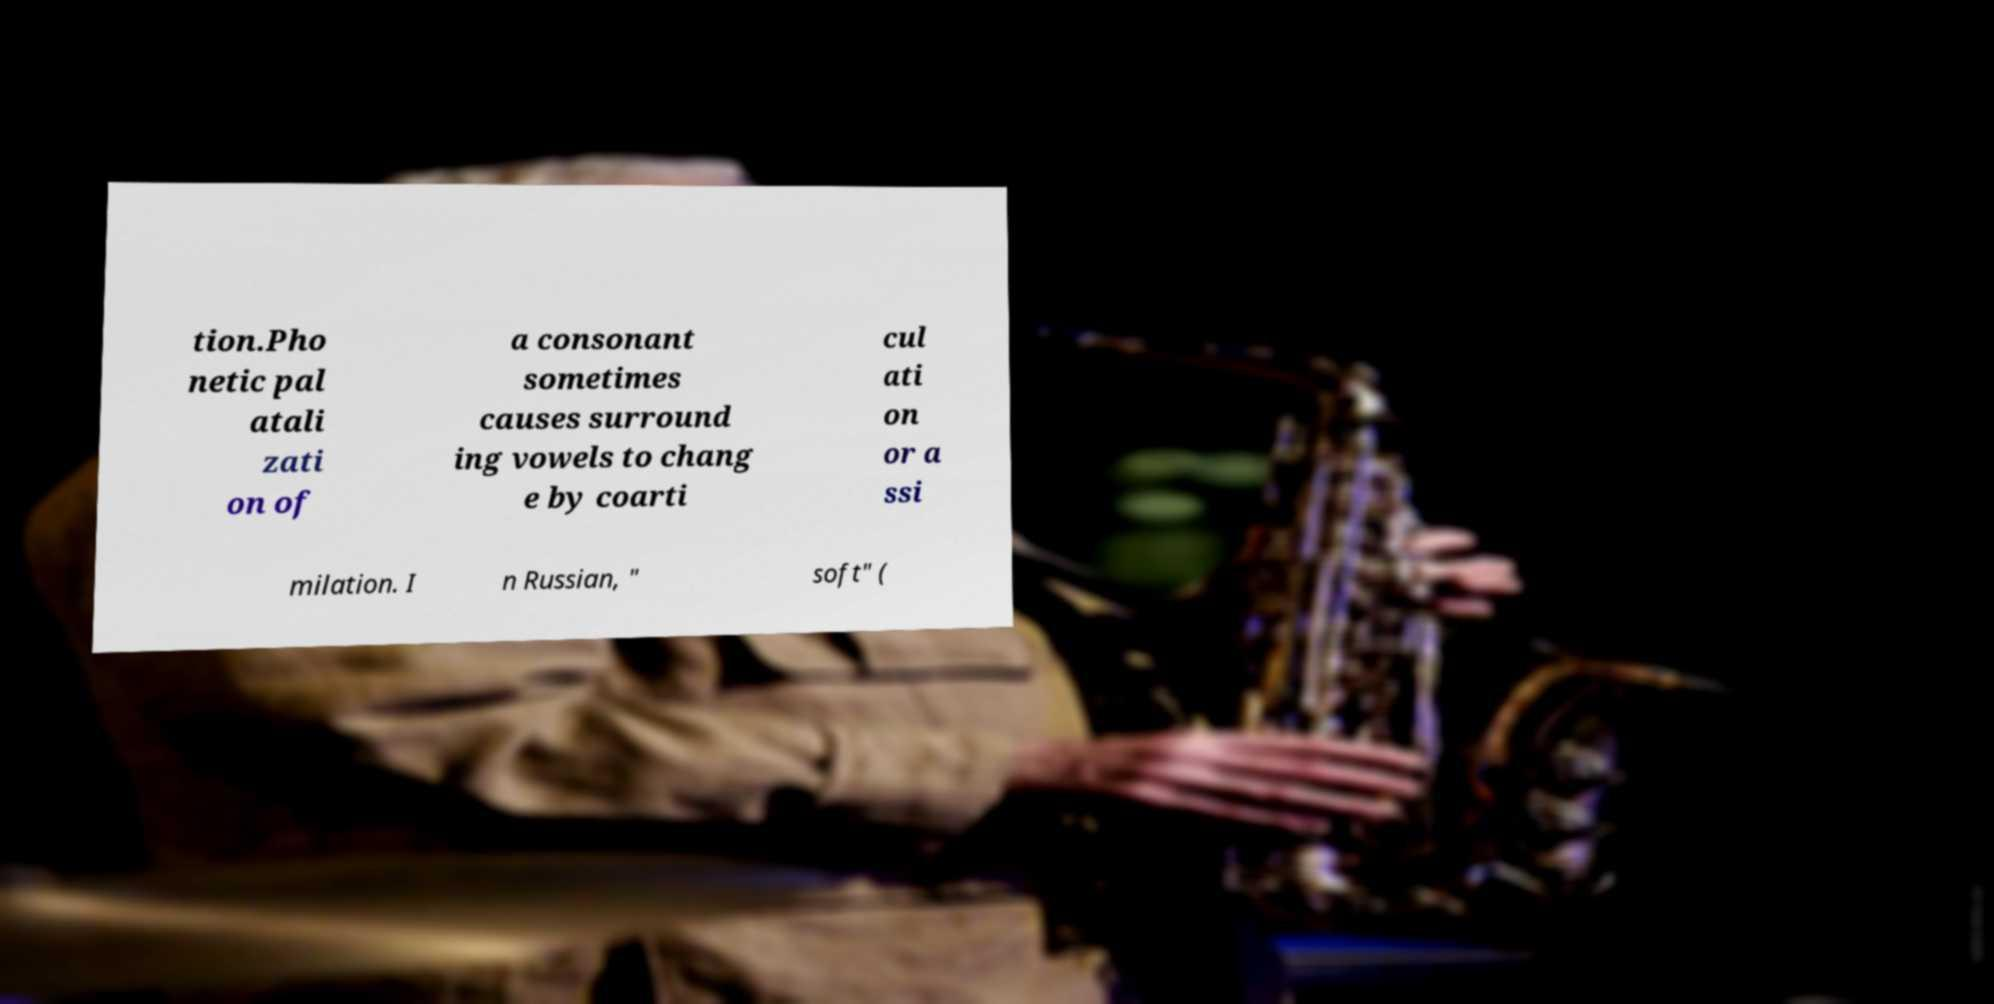What messages or text are displayed in this image? I need them in a readable, typed format. tion.Pho netic pal atali zati on of a consonant sometimes causes surround ing vowels to chang e by coarti cul ati on or a ssi milation. I n Russian, " soft" ( 